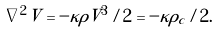<formula> <loc_0><loc_0><loc_500><loc_500>\nabla ^ { 2 } V = - \kappa \rho V ^ { 3 } / 2 = - \kappa \rho _ { c } / 2 .</formula> 